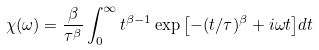Convert formula to latex. <formula><loc_0><loc_0><loc_500><loc_500>\chi ( \omega ) = \frac { \beta } { \tau ^ { \beta } } \int _ { 0 } ^ { \infty } t ^ { \beta - 1 } \exp { \left [ - ( t / \tau ) ^ { \beta } + i \omega t \right ] } d t</formula> 